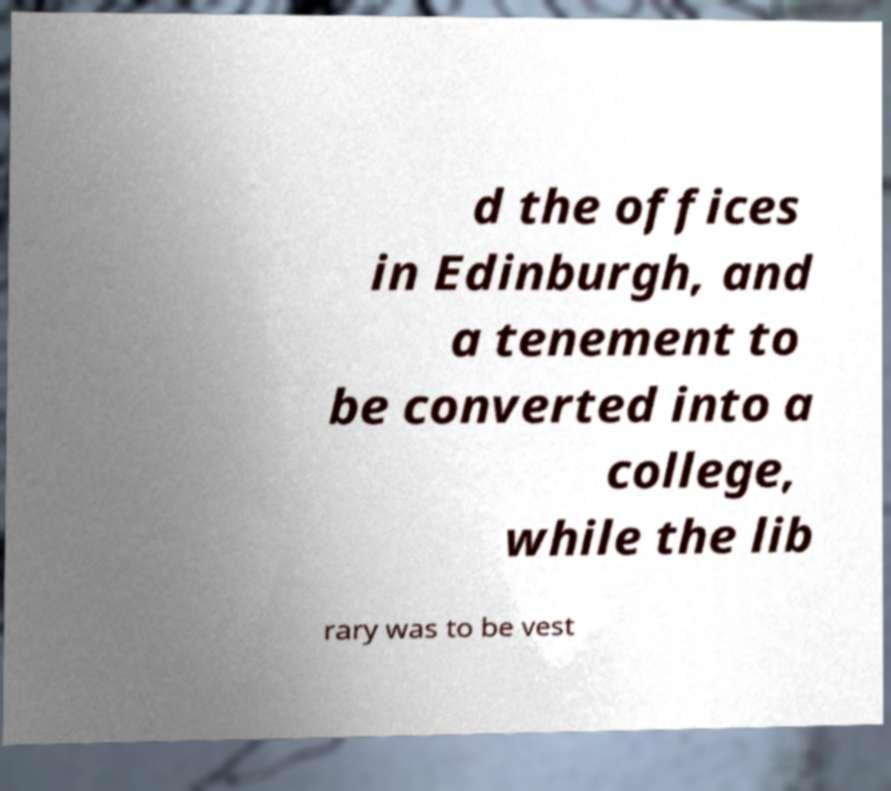There's text embedded in this image that I need extracted. Can you transcribe it verbatim? d the offices in Edinburgh, and a tenement to be converted into a college, while the lib rary was to be vest 